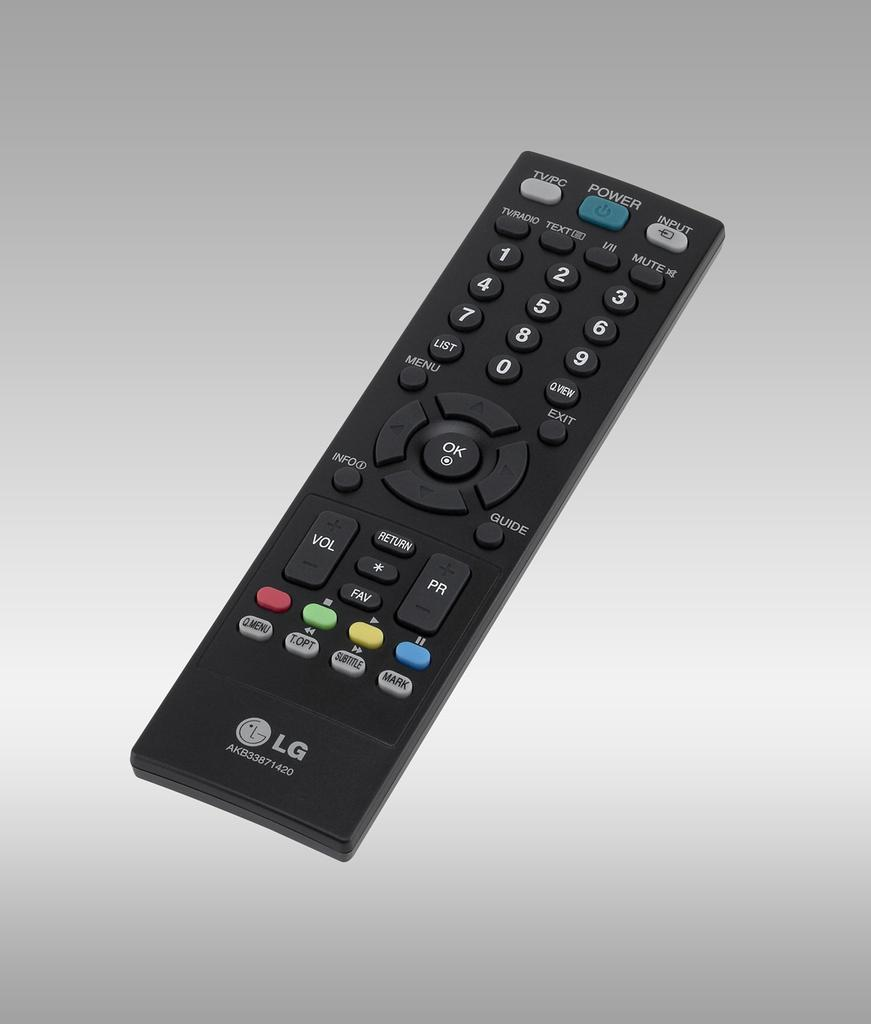Provide a one-sentence caption for the provided image. Black LG remote laying flat that works for a LG television. 